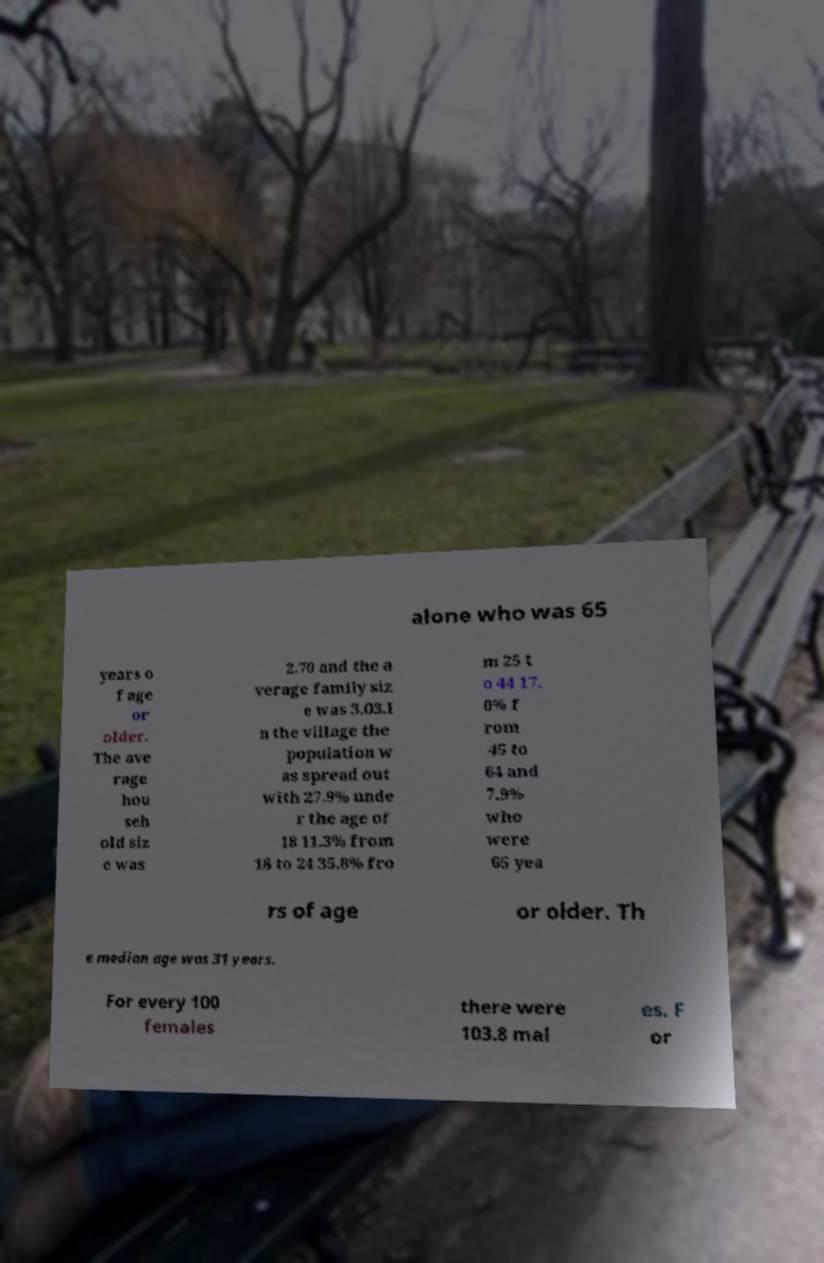Please read and relay the text visible in this image. What does it say? alone who was 65 years o f age or older. The ave rage hou seh old siz e was 2.70 and the a verage family siz e was 3.03.I n the village the population w as spread out with 27.9% unde r the age of 18 11.3% from 18 to 24 35.8% fro m 25 t o 44 17. 0% f rom 45 to 64 and 7.9% who were 65 yea rs of age or older. Th e median age was 31 years. For every 100 females there were 103.8 mal es. F or 